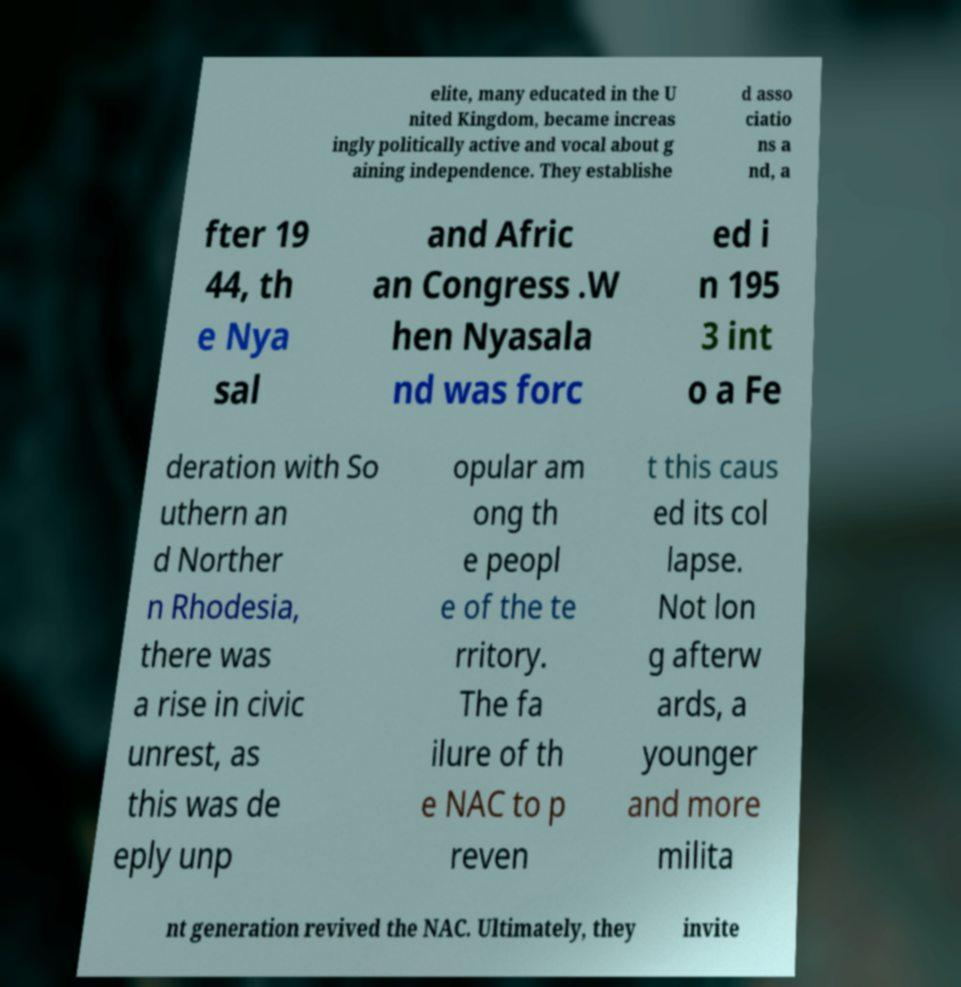Can you accurately transcribe the text from the provided image for me? elite, many educated in the U nited Kingdom, became increas ingly politically active and vocal about g aining independence. They establishe d asso ciatio ns a nd, a fter 19 44, th e Nya sal and Afric an Congress .W hen Nyasala nd was forc ed i n 195 3 int o a Fe deration with So uthern an d Norther n Rhodesia, there was a rise in civic unrest, as this was de eply unp opular am ong th e peopl e of the te rritory. The fa ilure of th e NAC to p reven t this caus ed its col lapse. Not lon g afterw ards, a younger and more milita nt generation revived the NAC. Ultimately, they invite 